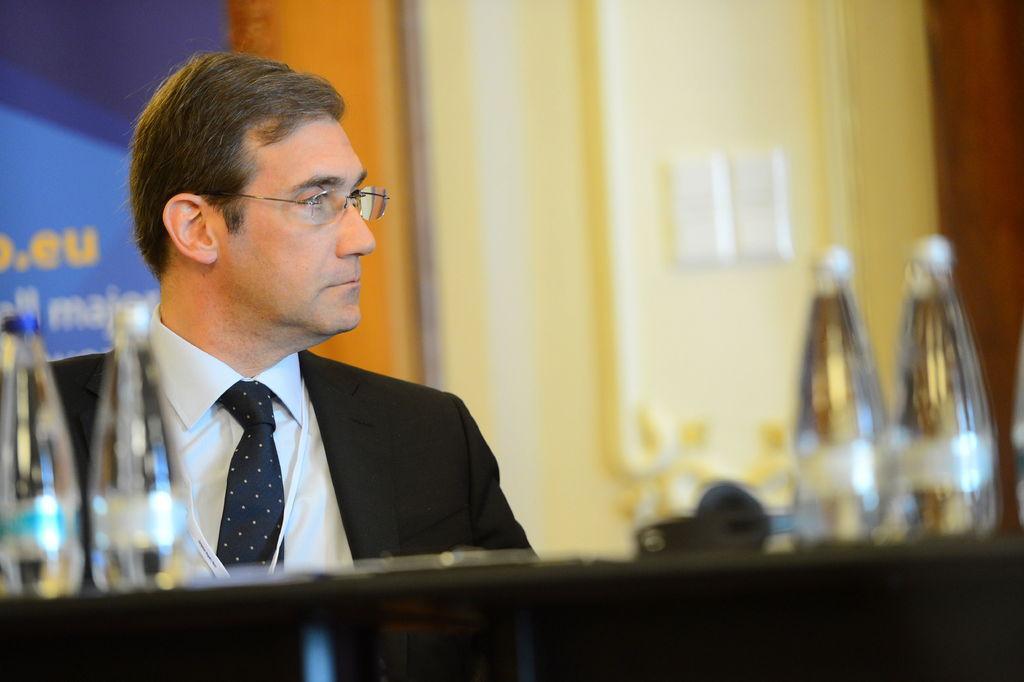Describe this image in one or two sentences. In this image, human in suit. There are few bottles are there in-front of him. Some other item is also placed on the table. And background, we can see blue, orange, yellow and red color. The man he wear a glasses. 